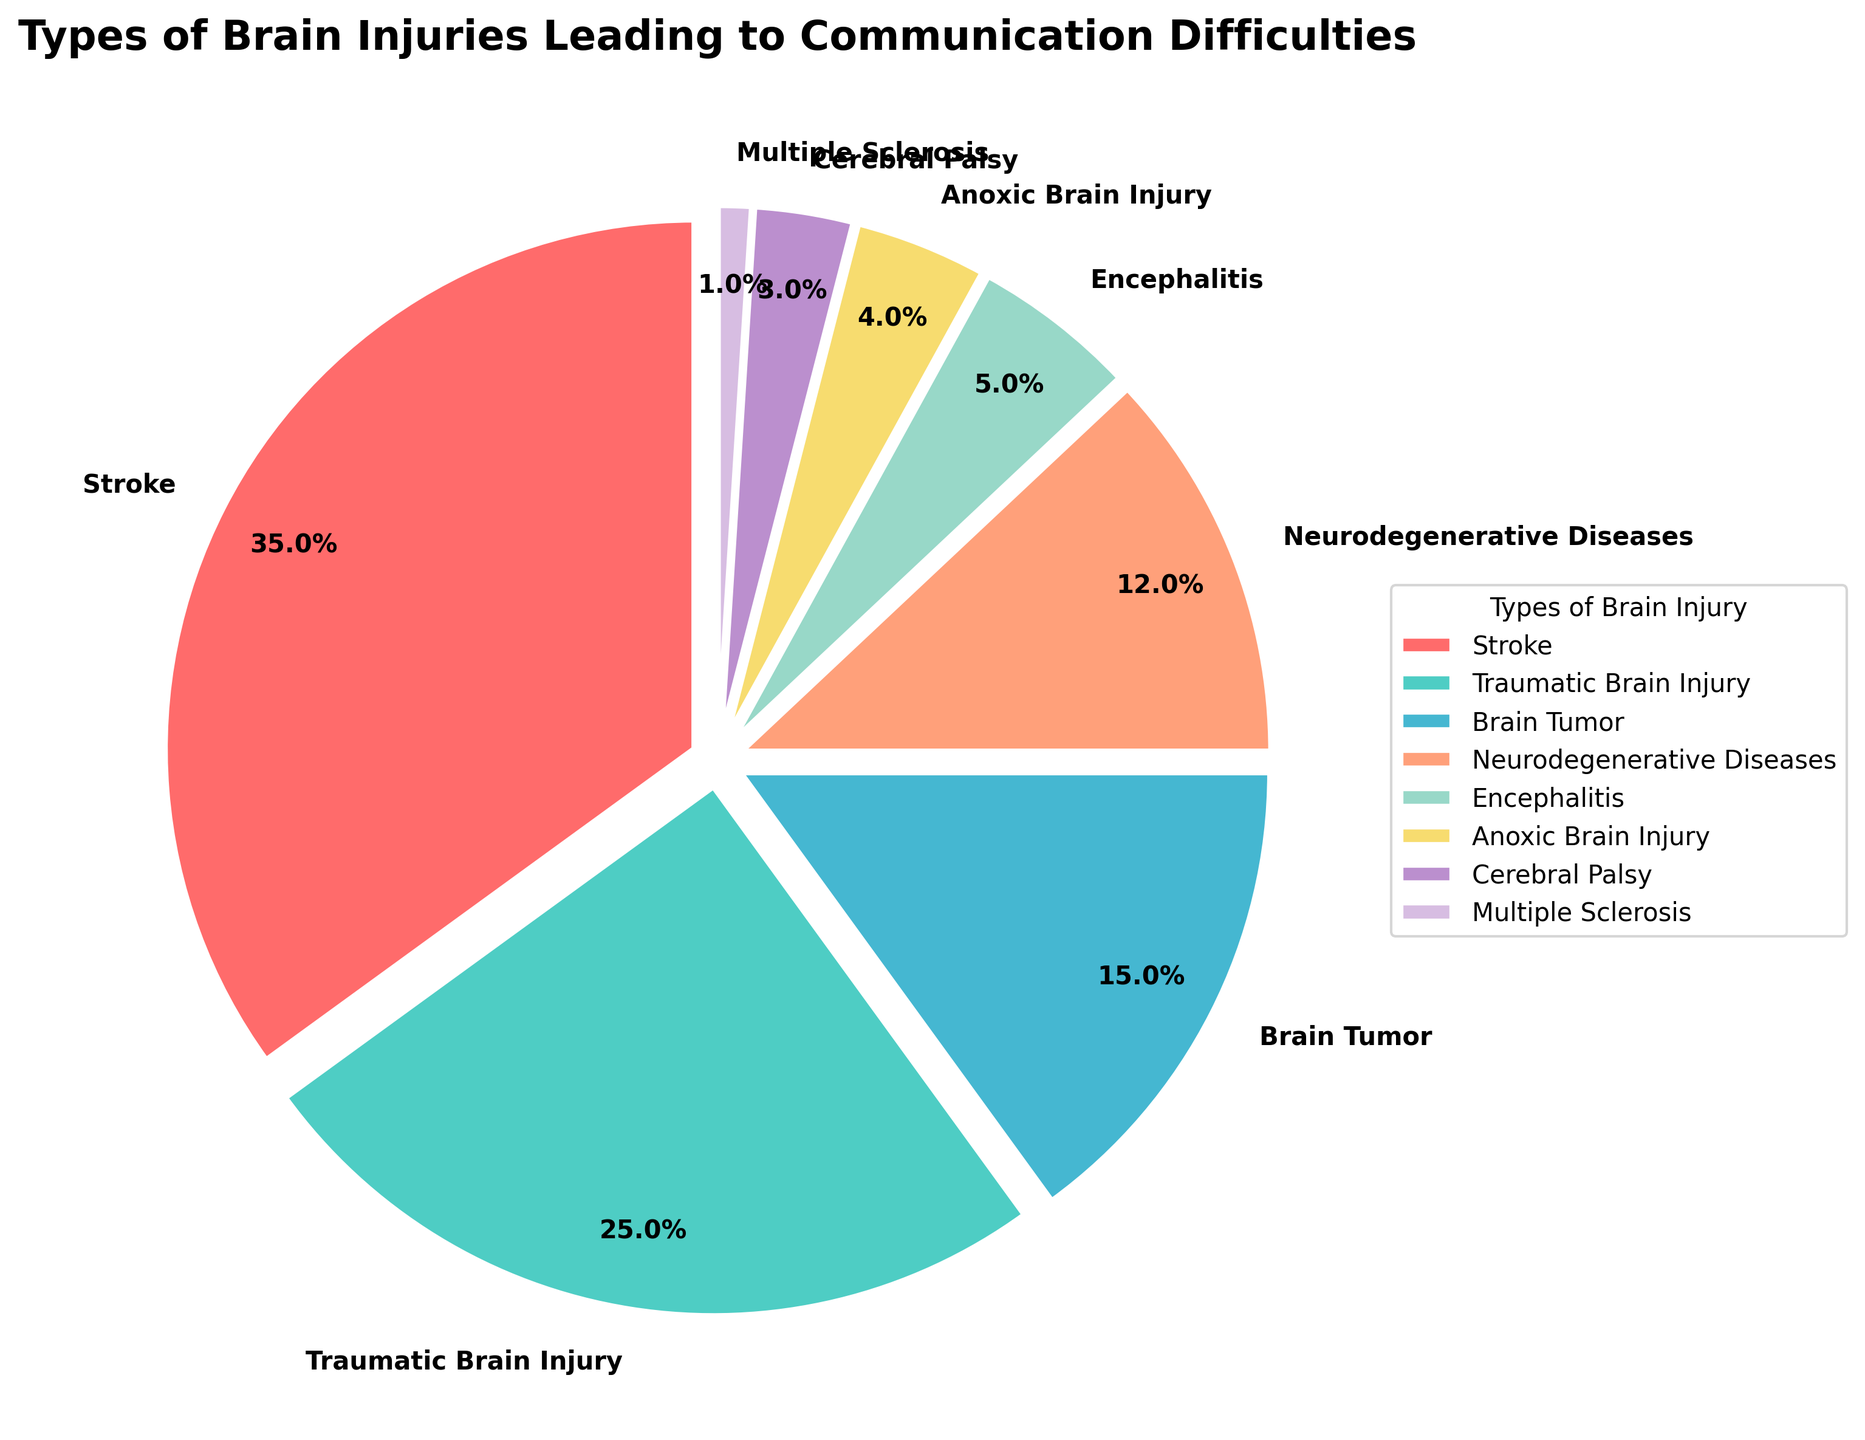What percentage of brain injuries leading to communication difficulties are caused by strokes and traumatic brain injuries combined? To find the combined percentage, add the percentages of strokes and traumatic brain injuries. Stroke has 35% and traumatic brain injury has 25%. So, 35% + 25% = 60%.
Answer: 60% Which type of brain injury is associated with the least percentage of communication difficulties? Look at the pie chart for the smallest section representing the least percentage. Multiple Sclerosis has the smallest section with 1%.
Answer: Multiple Sclerosis What is the sum of the percentages for brain tumors and encephalitis? Add the percentages for brain tumors and encephalitis. Brain tumors have 15% and encephalitis has 5%. So, 15% + 5% = 20%.
Answer: 20% Which types of brain injuries have percentages greater than 10%? Identify the sections of the pie chart with percentages greater than 10%. Stroke (35%), traumatic brain injury (25%), brain tumors (15%), and neurodegenerative diseases (12%) all have percentages greater than 10%.
Answer: Stroke, Traumatic Brain Injury, Brain Tumor, Neurodegenerative Diseases Compare the percentage of communication difficulties due to anoxic brain injury with those due to cerebral palsy. Anoxic brain injury has a percentage of 4%, and cerebral palsy has 3%. Thus, anoxic brain injury has a higher percentage by 1%.
Answer: Anoxic Brain Injury > Cerebral Palsy What is the average percentage of communication difficulties caused by encephalitis and multiple sclerosis? Add the percentages for encephalitis and multiple sclerosis, then divide by 2. Encephalitis has 5% and multiple sclerosis has 1%. (5% + 1%) / 2 = 3%.
Answer: 3% What are the colors used to represent traumatic brain injury and brain tumors? Refer to the colors depicted in the pie chart for these sections. Traumatic brain injury is represented in green, and brain tumors are in light blue.
Answer: Green and Light Blue 